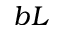Convert formula to latex. <formula><loc_0><loc_0><loc_500><loc_500>b L</formula> 